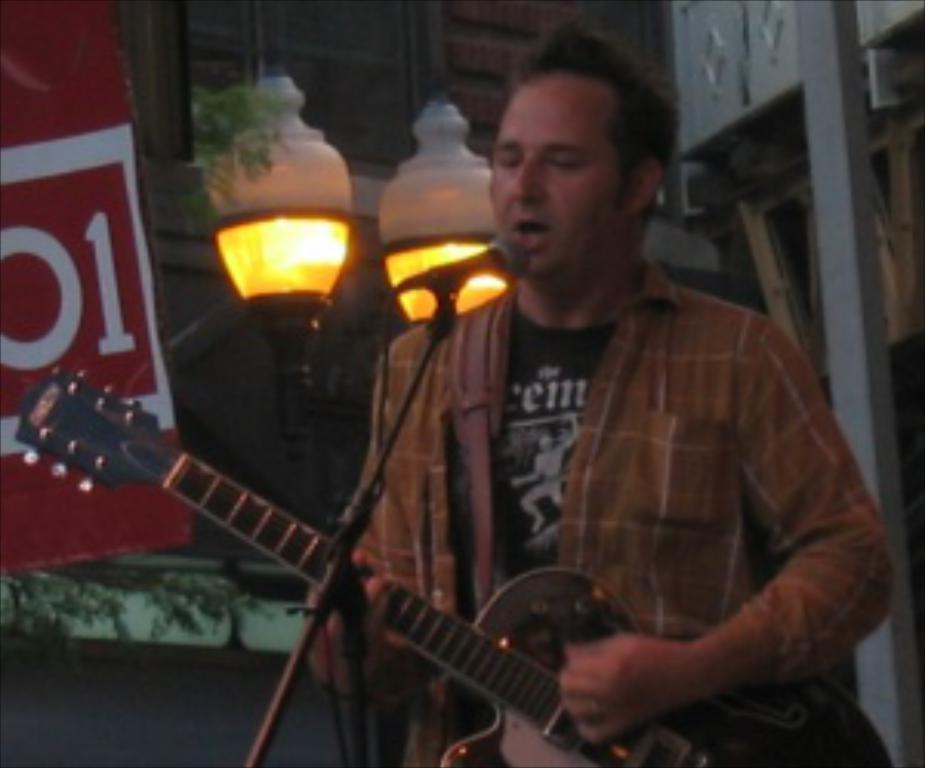Could you give a brief overview of what you see in this image? there is room the room has two big lamps and the person who is playing the guitar and singing the song he has opened mouth he is wearing black t-shirt and brown shirt. 